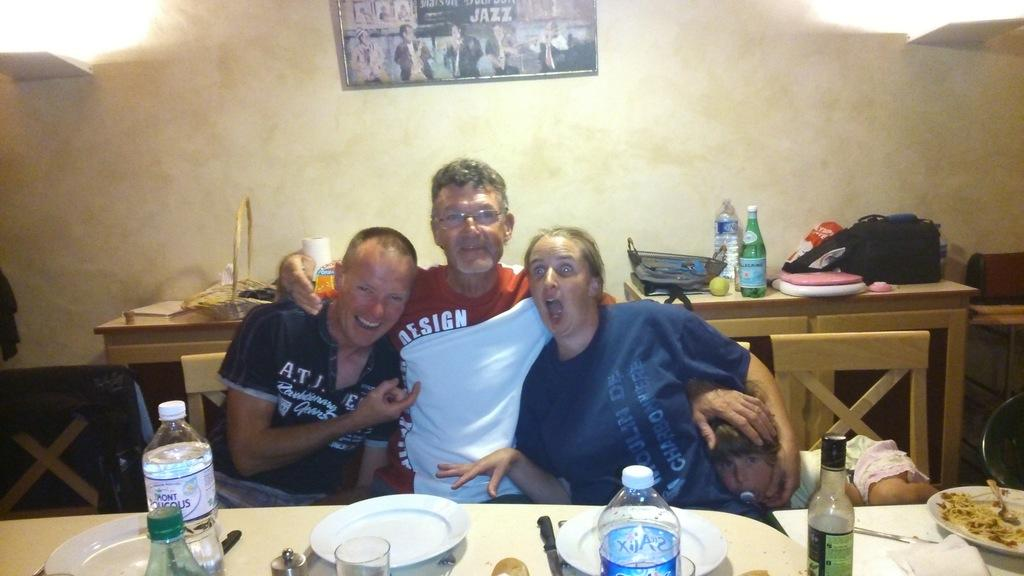How many people are in the image? There are four persons in the image. What are the persons doing in the image? The persons are sitting in chairs. Where are the chairs located in relation to the table? The chairs are in front of a table. What can be found on the table? The table has eatables and drinks on it. What is visible on the background wall? There is a picture on the background wall. What type of flower is growing on the knee of the person sitting on the left? There is no flower growing on the knee of any person in the image. 